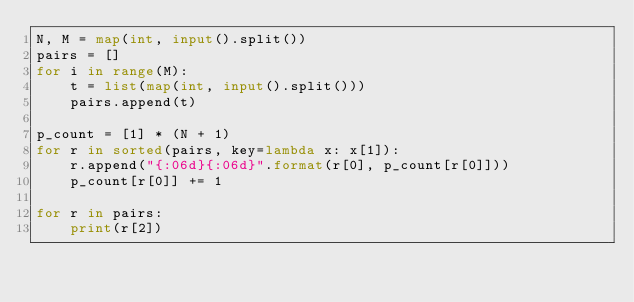Convert code to text. <code><loc_0><loc_0><loc_500><loc_500><_Python_>N, M = map(int, input().split())
pairs = []
for i in range(M):
    t = list(map(int, input().split()))
    pairs.append(t)

p_count = [1] * (N + 1)
for r in sorted(pairs, key=lambda x: x[1]):
    r.append("{:06d}{:06d}".format(r[0], p_count[r[0]]))
    p_count[r[0]] += 1

for r in pairs:
    print(r[2])
</code> 